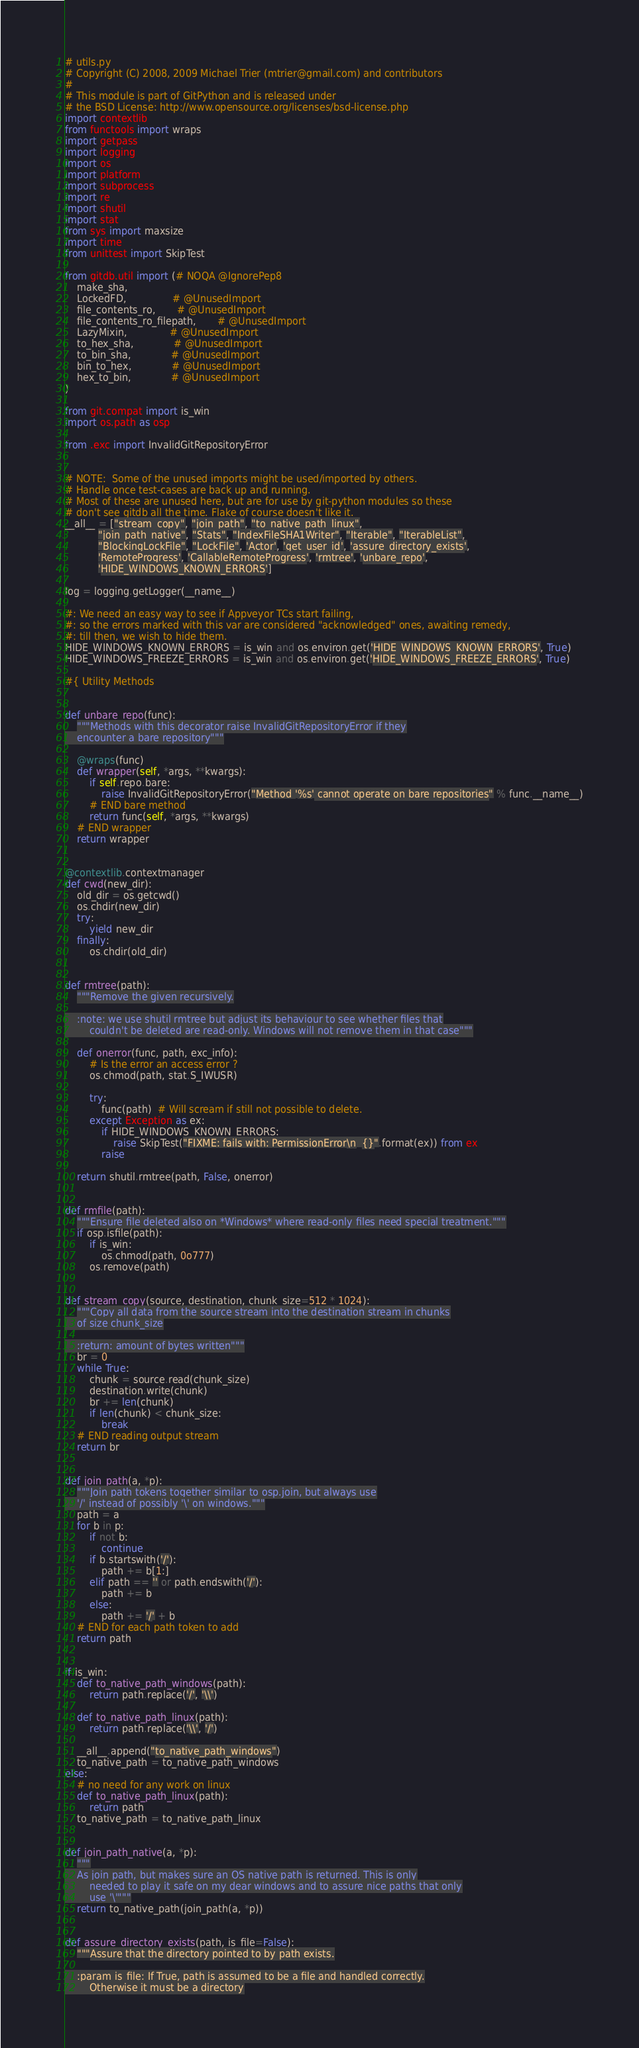Convert code to text. <code><loc_0><loc_0><loc_500><loc_500><_Python_># utils.py
# Copyright (C) 2008, 2009 Michael Trier (mtrier@gmail.com) and contributors
#
# This module is part of GitPython and is released under
# the BSD License: http://www.opensource.org/licenses/bsd-license.php
import contextlib
from functools import wraps
import getpass
import logging
import os
import platform
import subprocess
import re
import shutil
import stat
from sys import maxsize
import time
from unittest import SkipTest

from gitdb.util import (# NOQA @IgnorePep8
    make_sha,
    LockedFD,               # @UnusedImport
    file_contents_ro,       # @UnusedImport
    file_contents_ro_filepath,       # @UnusedImport
    LazyMixin,              # @UnusedImport
    to_hex_sha,             # @UnusedImport
    to_bin_sha,             # @UnusedImport
    bin_to_hex,             # @UnusedImport
    hex_to_bin,             # @UnusedImport
)

from git.compat import is_win
import os.path as osp

from .exc import InvalidGitRepositoryError


# NOTE:  Some of the unused imports might be used/imported by others.
# Handle once test-cases are back up and running.
# Most of these are unused here, but are for use by git-python modules so these
# don't see gitdb all the time. Flake of course doesn't like it.
__all__ = ["stream_copy", "join_path", "to_native_path_linux",
           "join_path_native", "Stats", "IndexFileSHA1Writer", "Iterable", "IterableList",
           "BlockingLockFile", "LockFile", 'Actor', 'get_user_id', 'assure_directory_exists',
           'RemoteProgress', 'CallableRemoteProgress', 'rmtree', 'unbare_repo',
           'HIDE_WINDOWS_KNOWN_ERRORS']

log = logging.getLogger(__name__)

#: We need an easy way to see if Appveyor TCs start failing,
#: so the errors marked with this var are considered "acknowledged" ones, awaiting remedy,
#: till then, we wish to hide them.
HIDE_WINDOWS_KNOWN_ERRORS = is_win and os.environ.get('HIDE_WINDOWS_KNOWN_ERRORS', True)
HIDE_WINDOWS_FREEZE_ERRORS = is_win and os.environ.get('HIDE_WINDOWS_FREEZE_ERRORS', True)

#{ Utility Methods


def unbare_repo(func):
    """Methods with this decorator raise InvalidGitRepositoryError if they
    encounter a bare repository"""

    @wraps(func)
    def wrapper(self, *args, **kwargs):
        if self.repo.bare:
            raise InvalidGitRepositoryError("Method '%s' cannot operate on bare repositories" % func.__name__)
        # END bare method
        return func(self, *args, **kwargs)
    # END wrapper
    return wrapper


@contextlib.contextmanager
def cwd(new_dir):
    old_dir = os.getcwd()
    os.chdir(new_dir)
    try:
        yield new_dir
    finally:
        os.chdir(old_dir)


def rmtree(path):
    """Remove the given recursively.

    :note: we use shutil rmtree but adjust its behaviour to see whether files that
        couldn't be deleted are read-only. Windows will not remove them in that case"""

    def onerror(func, path, exc_info):
        # Is the error an access error ?
        os.chmod(path, stat.S_IWUSR)

        try:
            func(path)  # Will scream if still not possible to delete.
        except Exception as ex:
            if HIDE_WINDOWS_KNOWN_ERRORS:
                raise SkipTest("FIXME: fails with: PermissionError\n  {}".format(ex)) from ex
            raise

    return shutil.rmtree(path, False, onerror)


def rmfile(path):
    """Ensure file deleted also on *Windows* where read-only files need special treatment."""
    if osp.isfile(path):
        if is_win:
            os.chmod(path, 0o777)
        os.remove(path)


def stream_copy(source, destination, chunk_size=512 * 1024):
    """Copy all data from the source stream into the destination stream in chunks
    of size chunk_size

    :return: amount of bytes written"""
    br = 0
    while True:
        chunk = source.read(chunk_size)
        destination.write(chunk)
        br += len(chunk)
        if len(chunk) < chunk_size:
            break
    # END reading output stream
    return br


def join_path(a, *p):
    """Join path tokens together similar to osp.join, but always use
    '/' instead of possibly '\' on windows."""
    path = a
    for b in p:
        if not b:
            continue
        if b.startswith('/'):
            path += b[1:]
        elif path == '' or path.endswith('/'):
            path += b
        else:
            path += '/' + b
    # END for each path token to add
    return path


if is_win:
    def to_native_path_windows(path):
        return path.replace('/', '\\')

    def to_native_path_linux(path):
        return path.replace('\\', '/')

    __all__.append("to_native_path_windows")
    to_native_path = to_native_path_windows
else:
    # no need for any work on linux
    def to_native_path_linux(path):
        return path
    to_native_path = to_native_path_linux


def join_path_native(a, *p):
    """
    As join path, but makes sure an OS native path is returned. This is only
        needed to play it safe on my dear windows and to assure nice paths that only
        use '\'"""
    return to_native_path(join_path(a, *p))


def assure_directory_exists(path, is_file=False):
    """Assure that the directory pointed to by path exists.

    :param is_file: If True, path is assumed to be a file and handled correctly.
        Otherwise it must be a directory</code> 